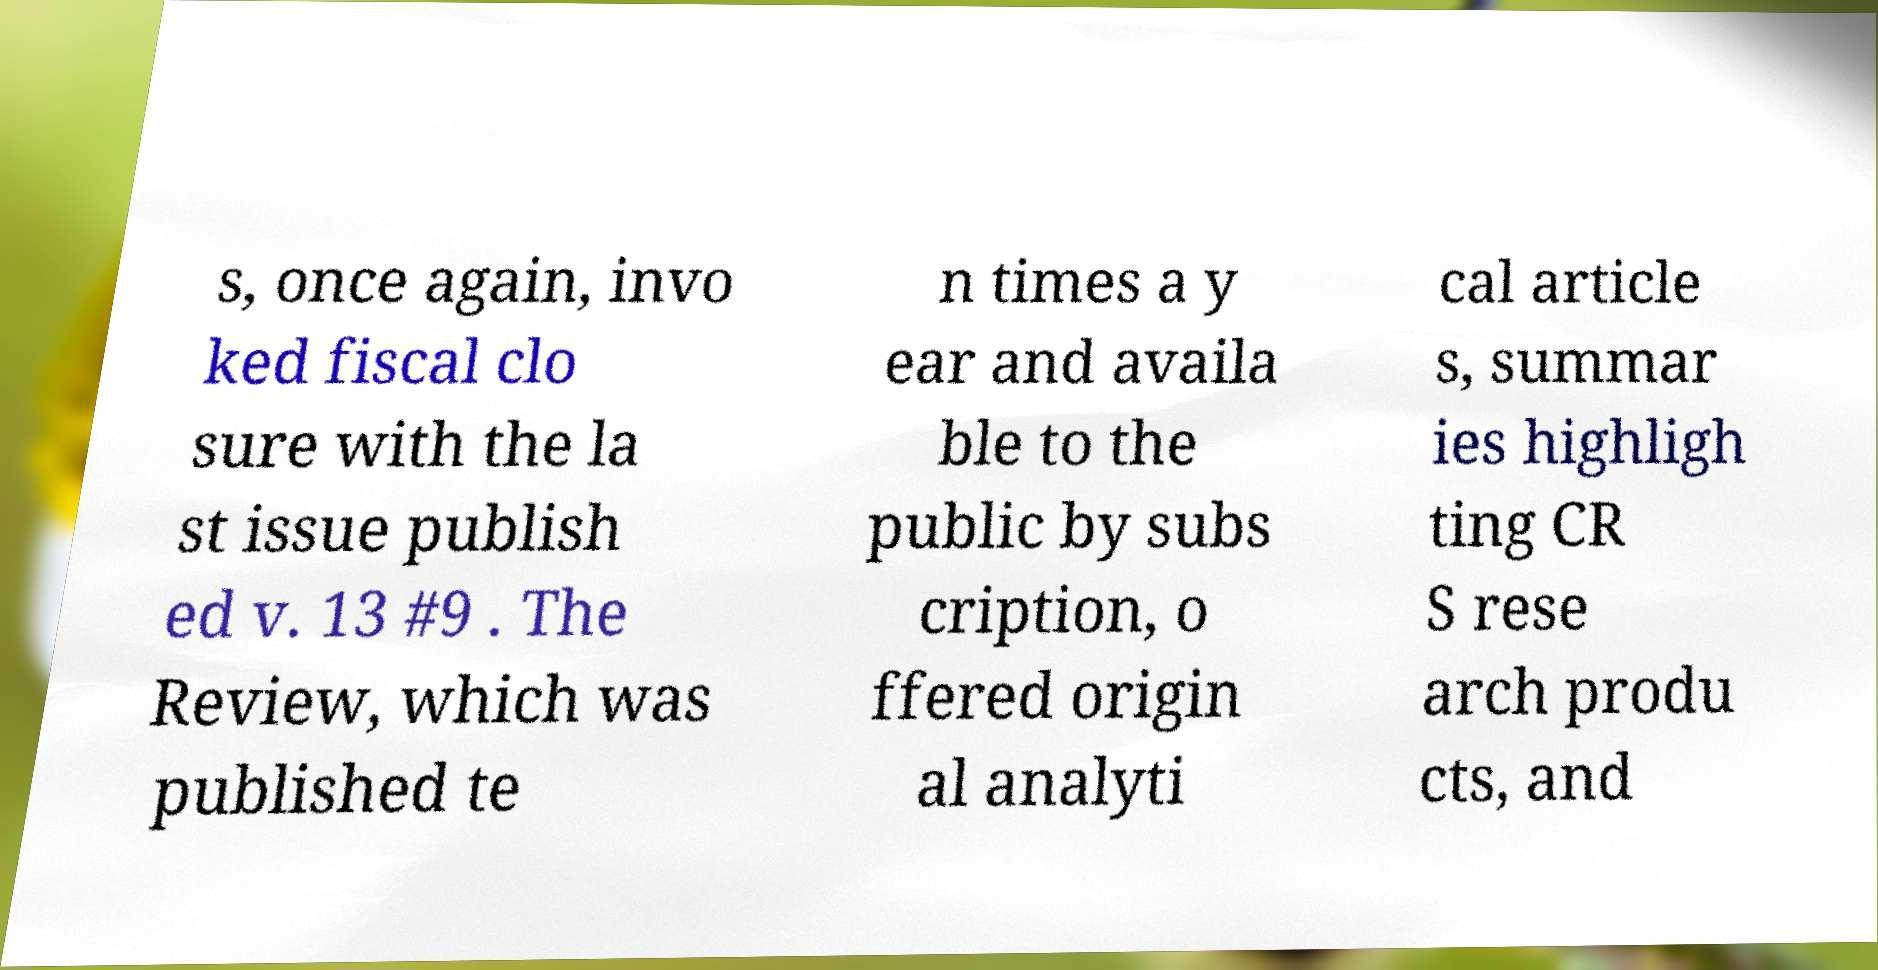What messages or text are displayed in this image? I need them in a readable, typed format. s, once again, invo ked fiscal clo sure with the la st issue publish ed v. 13 #9 . The Review, which was published te n times a y ear and availa ble to the public by subs cription, o ffered origin al analyti cal article s, summar ies highligh ting CR S rese arch produ cts, and 